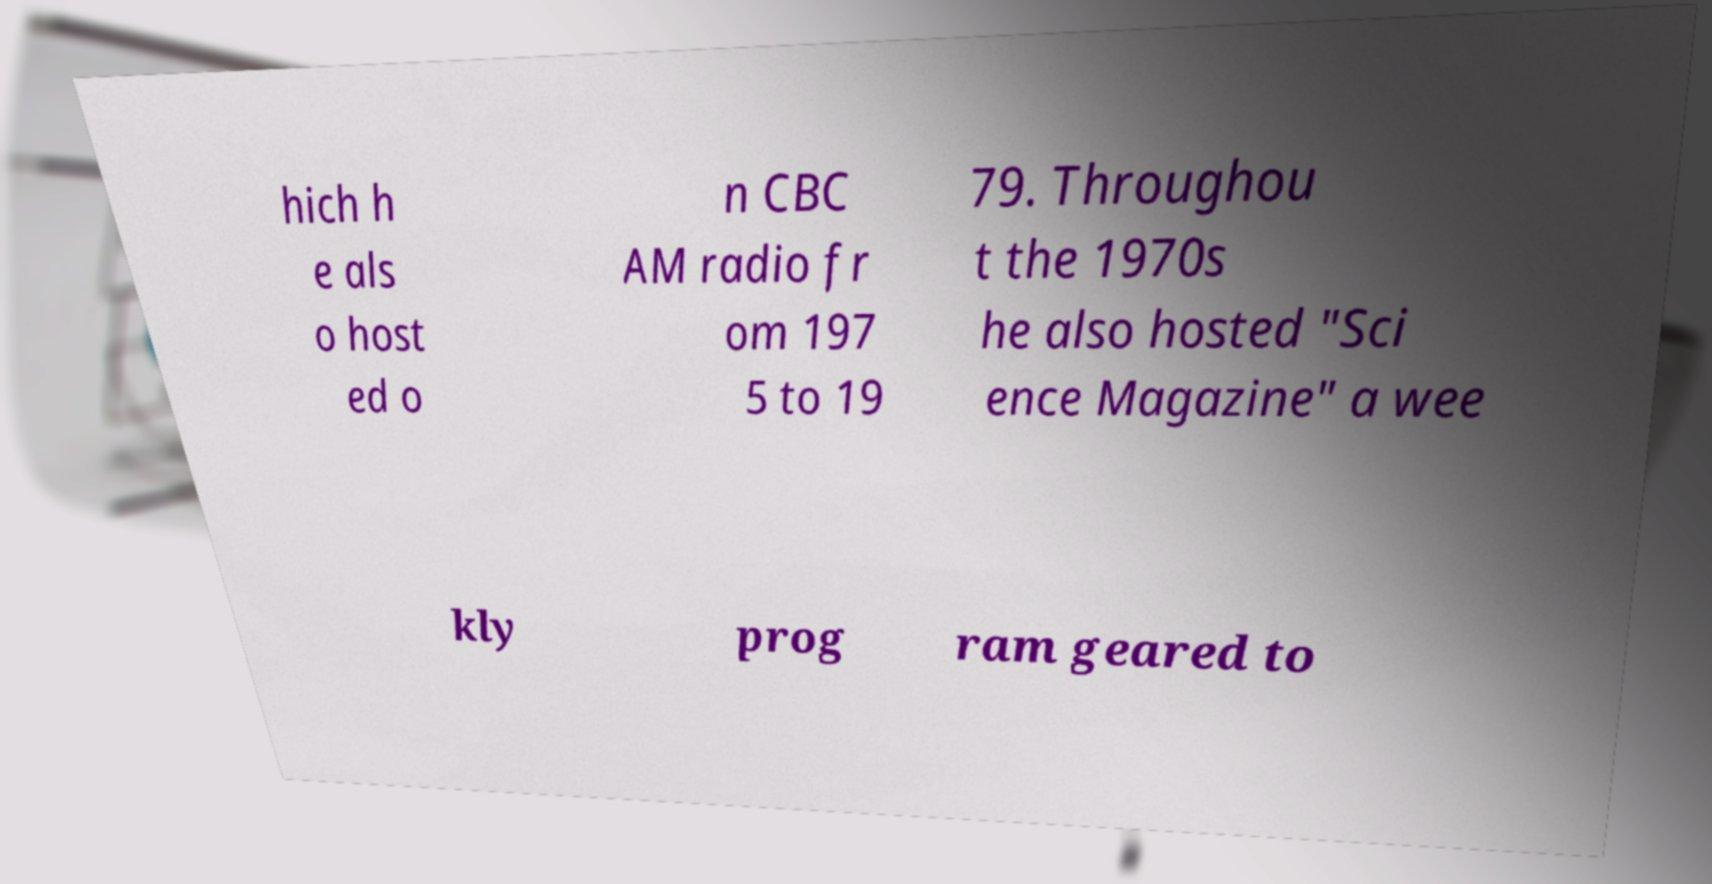For documentation purposes, I need the text within this image transcribed. Could you provide that? hich h e als o host ed o n CBC AM radio fr om 197 5 to 19 79. Throughou t the 1970s he also hosted "Sci ence Magazine" a wee kly prog ram geared to 